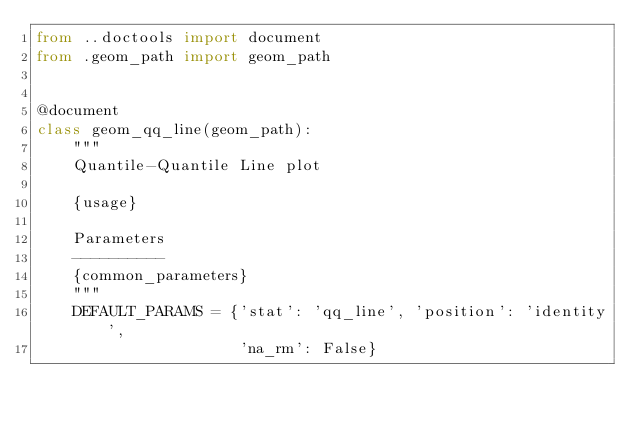<code> <loc_0><loc_0><loc_500><loc_500><_Python_>from ..doctools import document
from .geom_path import geom_path


@document
class geom_qq_line(geom_path):
    """
    Quantile-Quantile Line plot

    {usage}

    Parameters
    ----------
    {common_parameters}
    """
    DEFAULT_PARAMS = {'stat': 'qq_line', 'position': 'identity',
                      'na_rm': False}
</code> 